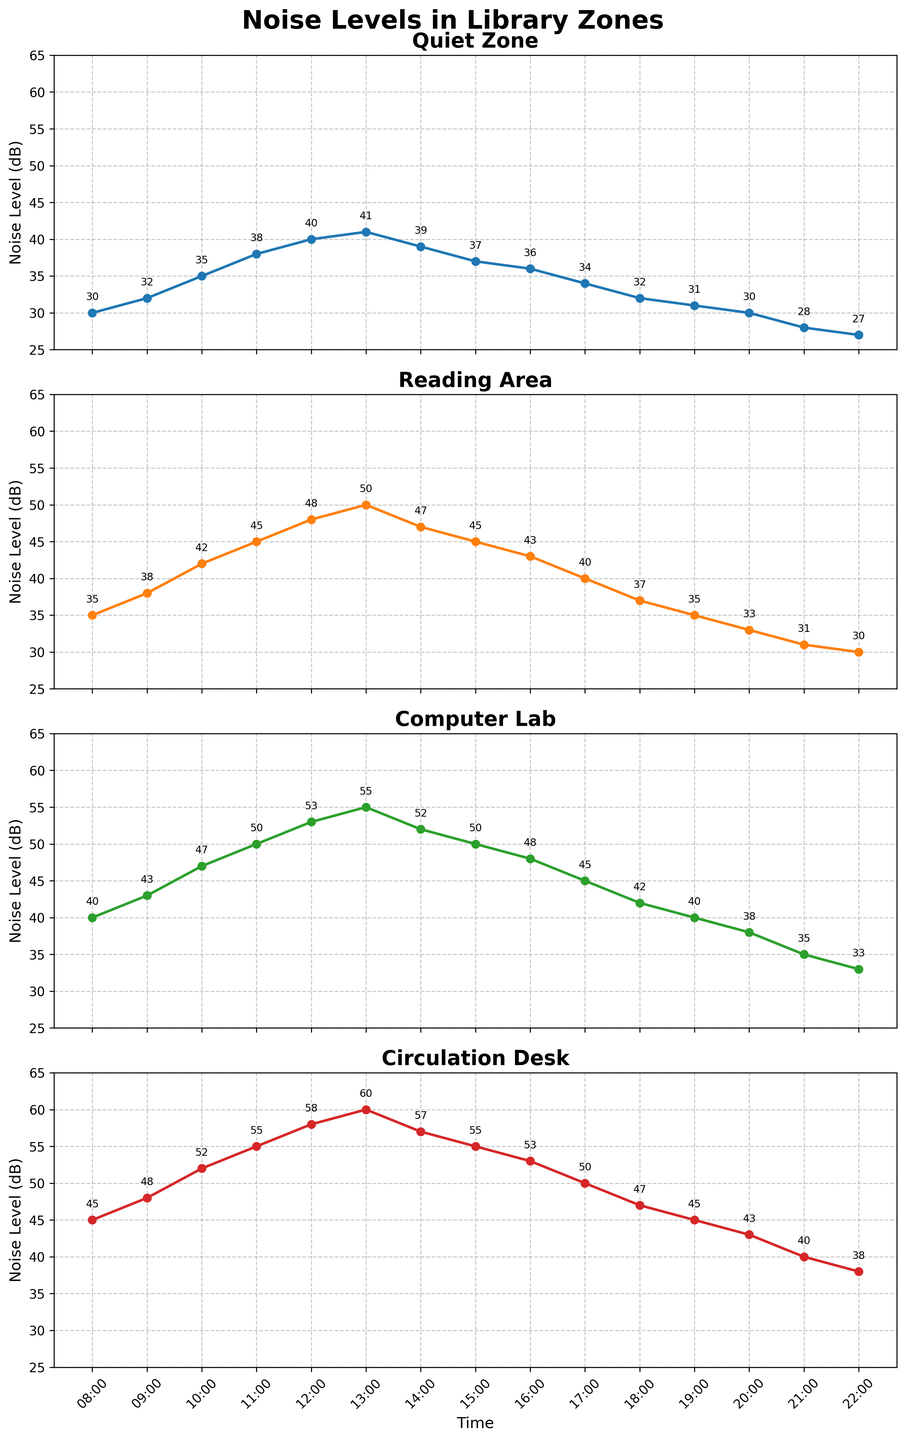Which library zone has the highest noise level at 12:00? At 12:00, compare the noise levels of all four zones. The highest value among Quiet Zone (40), Reading Area (48), Computer Lab (53), and Circulation Desk (58) is 58 in Circulation Desk.
Answer: Circulation Desk Across all times, which zone consistently demonstrates the lowest noise levels? Examine the plots for each library zone to determine which consistently shows the lowest noise levels. The Quiet Zone has the lowest noise levels among the other zones consistently.
Answer: Quiet Zone What is the average noise level at 10:00 and 16:00 in the Computer Lab? Calculate the average noise level at 10:00 (47 dB) and 16:00 (48 dB) by summing the values and dividing by 2: (47 + 48) / 2 = 47.5 dB.
Answer: 47.5 dB During which time period does the Reading Area experience the maximum noise level? Review the plot for the Reading Area and identify the time with the highest noise level. The peak noise level of 50 dB occurs at 13:00.
Answer: 13:00 How does the noise level trend change in the Quiet Zone from 19:00 to 22:00? Observe the plot for the Quiet Zone between 19:00 and 22:00. The noise level decreases from 31 dB (19:00) to 28 dB (21:00) and further decreases to 27 dB (22:00).
Answer: Decreasing What's the difference in noise level in the Circulation Desk at 08:00 and 20:00? Subtract the noise level at 20:00 (43 dB) from the noise level at 08:00 (45 dB): 45 - 43 = 2 dB.
Answer: 2 dB What time shows the median noise level in the Quiet Zone? List all noise levels in the Quiet Zone: [30, 32, 35, 38, 40, 41, 39, 37, 36, 34, 32, 31, 30, 28, 27]. The median value is the 8th number when the list is sorted, which is 35 at 10:00.
Answer: 10:00 Compare the noise levels at 15:00 between Reading Area and Computer Lab. Which is higher and by how much? At 15:00, the Reading Area has 45 dB and the Computer Lab has 50 dB. The Computer Lab is higher by 50 - 45 = 5 dB.
Answer: Computer Lab, 5 dB What is the overall trend of noise levels in the Circulation Desk from 08:00 to 22:00? Examine the entire plot for the Circulation Desk from 08:00 to 22:00. It shows an overall decreasing trend, starting from 45 dB at 08:00 and lowering to 38 dB at 22:00.
Answer: Decreasing 